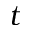Convert formula to latex. <formula><loc_0><loc_0><loc_500><loc_500>t</formula> 